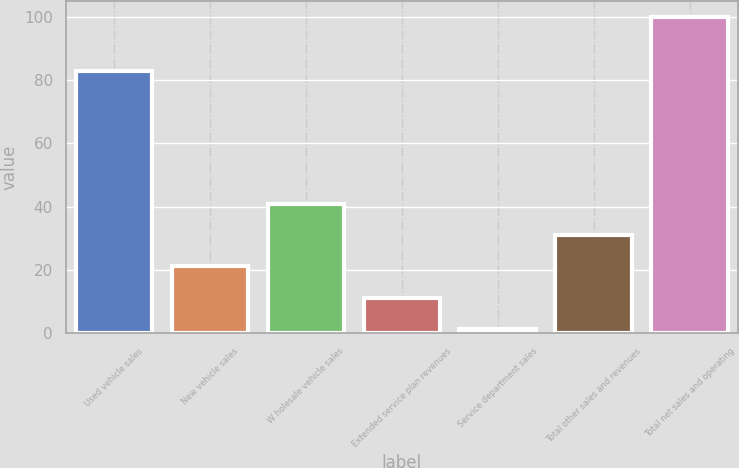Convert chart. <chart><loc_0><loc_0><loc_500><loc_500><bar_chart><fcel>Used vehicle sales<fcel>New vehicle sales<fcel>W holesale vehicle sales<fcel>Extended service plan revenues<fcel>Service department sales<fcel>Total other sales and revenues<fcel>Total net sales and operating<nl><fcel>82.9<fcel>21.12<fcel>40.84<fcel>11.26<fcel>1.4<fcel>30.98<fcel>100<nl></chart> 